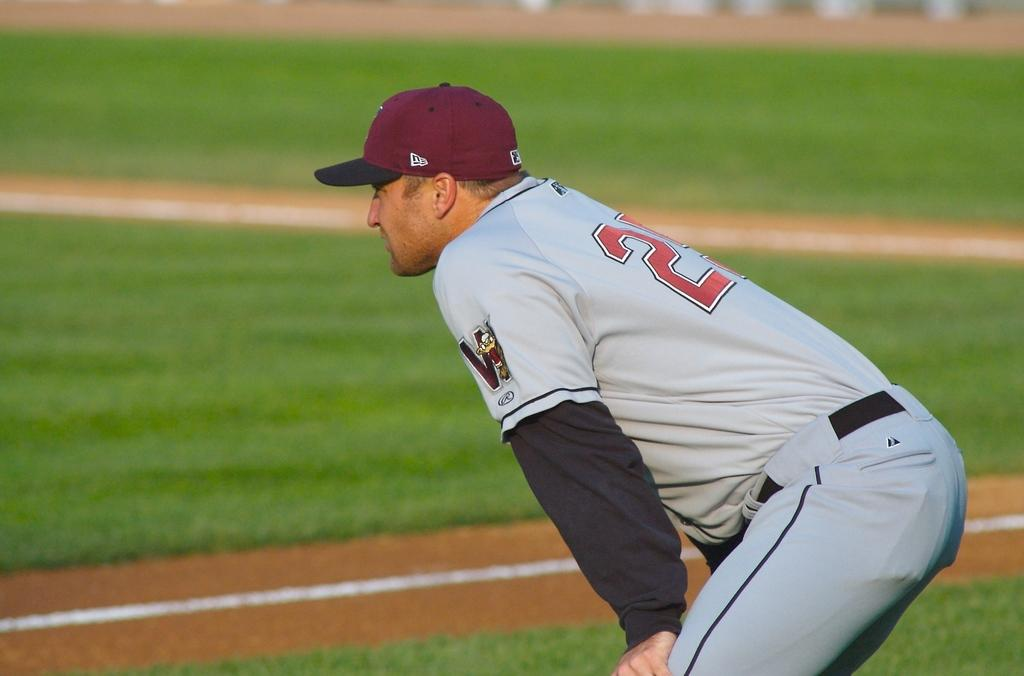What type of vegetation is present in the image? There is grass in the image. Who is present in the image? There is a man in the image. What is the man wearing on his head? The man is wearing a cap. What color is the man's dress? The man is wearing a white color dress. What type of argument is the man having with the grass in the image? There is no argument present in the image; it only shows a man wearing a cap and a white dress standing in grass. What are the man's hobbies, as depicted in the image? The image does not provide any information about the man's hobbies. 